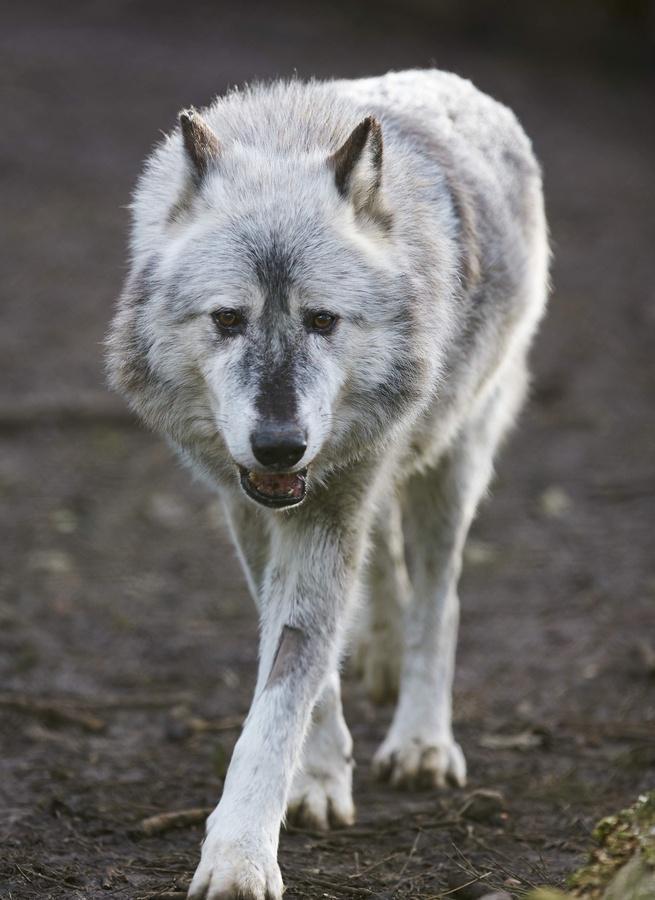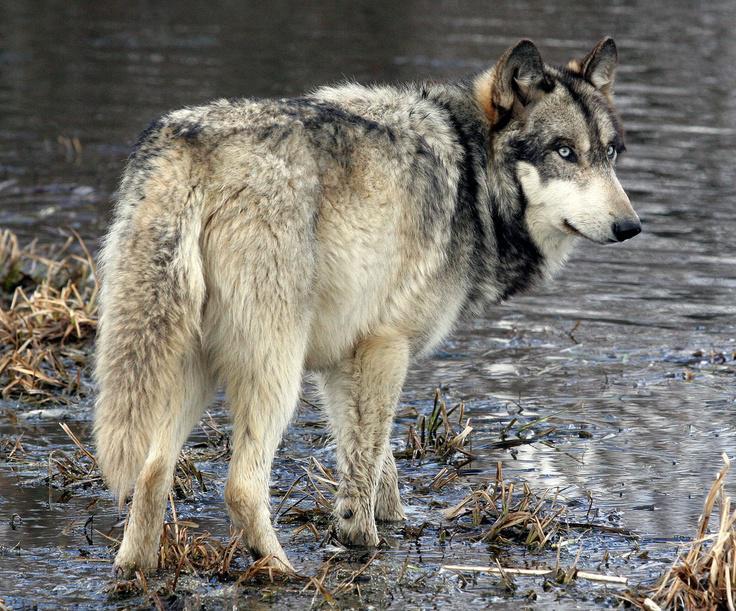The first image is the image on the left, the second image is the image on the right. Evaluate the accuracy of this statement regarding the images: "An image shows a wolf walking forward, in the general direction of the camera.". Is it true? Answer yes or no. Yes. 